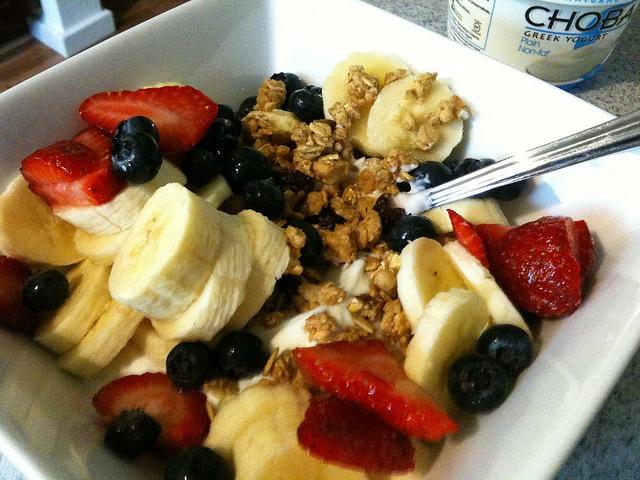Is there granola in the bowl?
Write a very short answer. Yes. What kind of yogurt is it?
Be succinct. Vanilla. Which fruits are shown?
Write a very short answer. Strawberries, bananas, blueberries. 